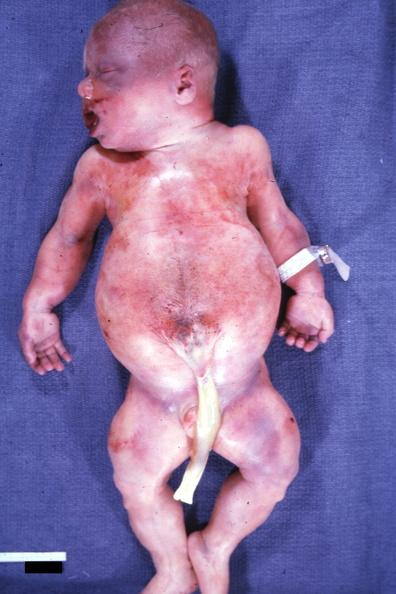what is present?
Answer the question using a single word or phrase. Beckwith-wiedemann syndrome 